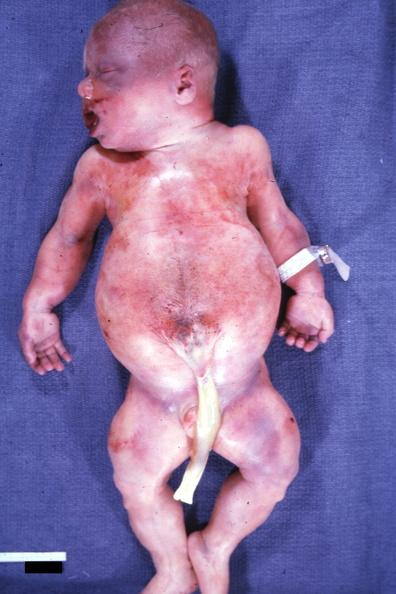what is present?
Answer the question using a single word or phrase. Beckwith-wiedemann syndrome 